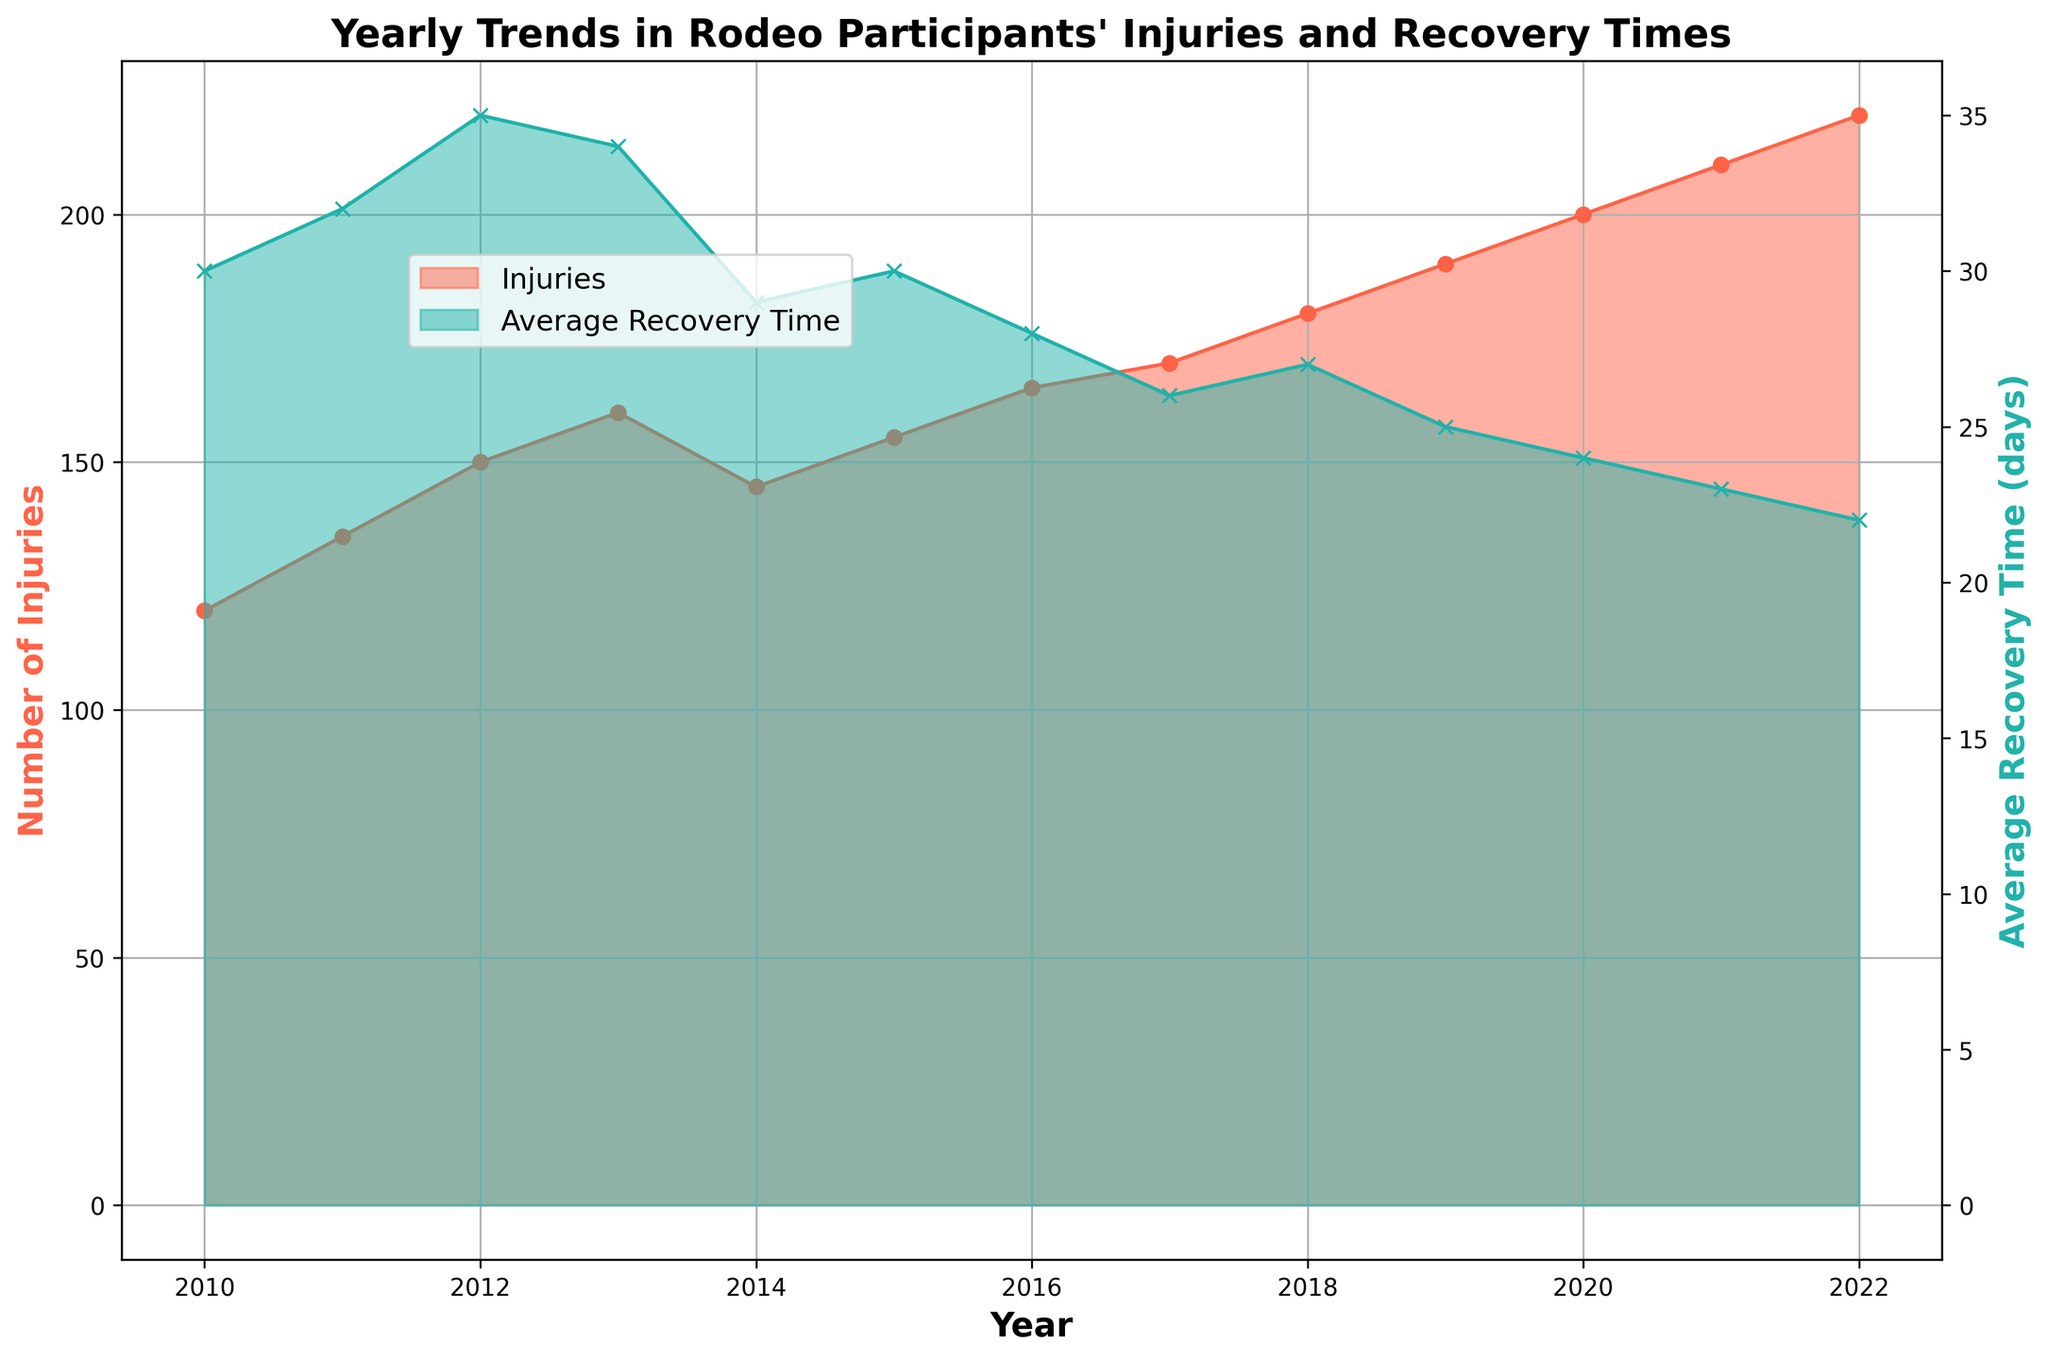How has the number of injuries changed from 2010 to 2022? By observing the chart, we can see the height of the red filled area representing injuries. It starts at 120 in 2010 and steadily increases to 220 in 2022.
Answer: They increased What is the trend in the average recovery time from 2010 to 2022? By looking at the green filled area representing recovery times, we observe that the height decreases over the years from 30 days in 2010 to 22 days in 2022.
Answer: It decreased In which year did the average recovery time start to decline significantly? Carefully observing the green area, we notice a significant drop after 2015, going from 30 days to 28 days.
Answer: 2016 Compare the number of injuries in 2014 and 2019. Which year had more injuries, and by how much? The height of the red area shows that injuries in 2014 were 145, and in 2019 they were 190. Calculating the difference: 190 - 145 = 45.
Answer: 2019 had 45 more injuries Did the average recovery time ever get below 24 days? If so, when did this happen? By observing the green line, we see that the average recovery time dropped below 24 days starting from 2021 (23 days) and continued to 2022 (22 days).
Answer: Yes, in 2021 and 2022 What is the difference in the number of injuries between the highest and lowest years? Observing the red area, the lowest number of injuries is 120 in 2010 and the highest is 220 in 2022. The difference is 220 - 120 = 100.
Answer: 100 How did the trends in injuries and recovery times correlate over the years? The red area for injuries increased each year, while the green area for recovery times generally decreased, indicating that as injuries became more common, recovery times got shorter.
Answer: Inversely correlated Which year had the highest number of injuries, and what was the average recovery time that year? The peak of the red area shows the highest injuries in 2022 with 220 injuries, and the green area indicates the recovery time that year was 22 days.
Answer: 2022, 22 days In which period did the number of injuries see the most rapid increase? By comparing the steepness of the red area, the most rapid increase occurred between 2018 and 2020, where it jumps from 180 to 200 injuries.
Answer: 2018-2020 Is there a year where both injuries increased and recovery time decreased significantly? Between 2015 and 2016, injuries increased from 155 to 165 while recovery time decreased from 30 to 28. This dual change is significant.
Answer: 2016 